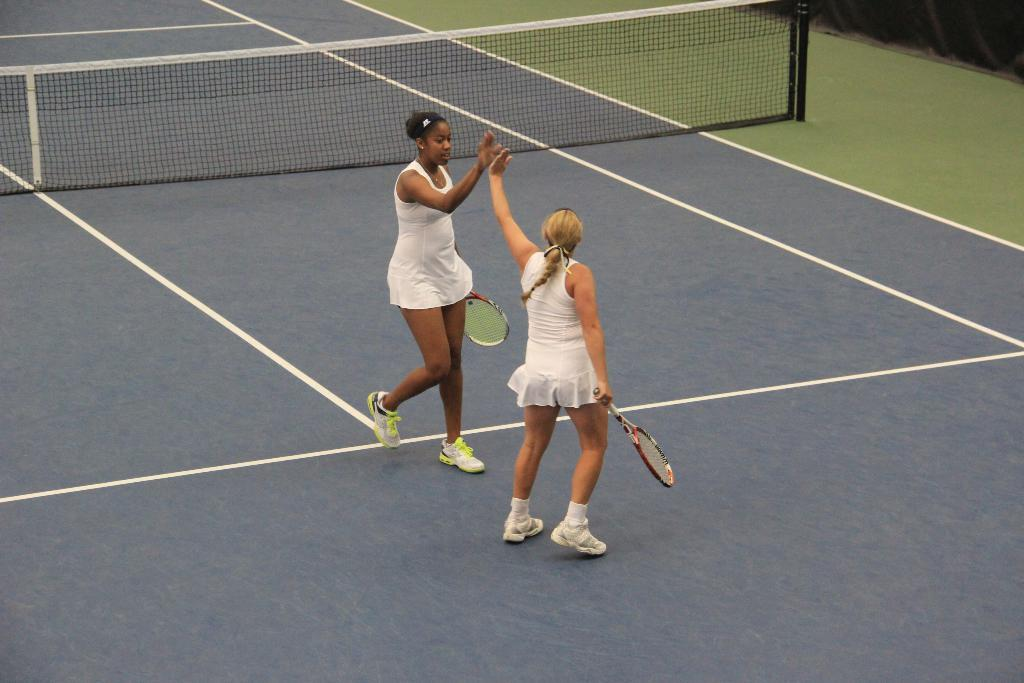What are the people in the image doing? The people in the image are standing and holding a bat. What are the people wearing? The people are wearing white-colored dress. What can be seen in the background of the image? There is a net visible in the background of the image. What type of government is depicted in the image? There is no depiction of a government in the image; it features people holding a bat and wearing white-colored dress. What song is being played in the background of the image? There is no music or song playing in the image; it only shows people holding a bat and wearing white-colored dress with a net visible in the background. 